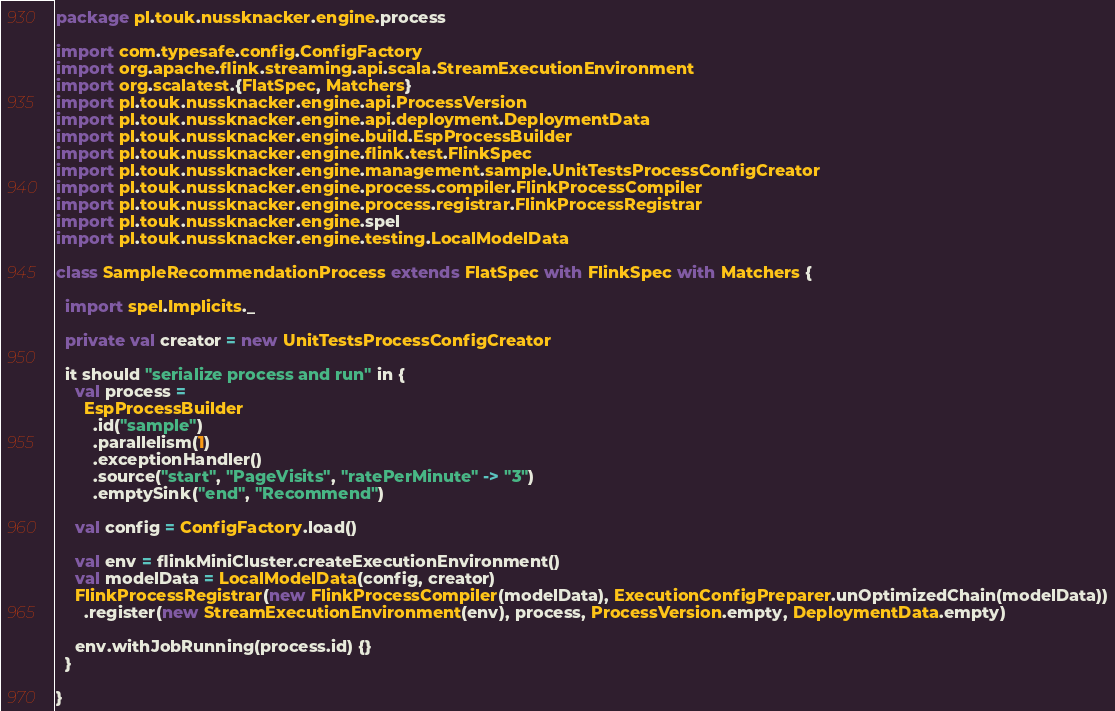Convert code to text. <code><loc_0><loc_0><loc_500><loc_500><_Scala_>package pl.touk.nussknacker.engine.process

import com.typesafe.config.ConfigFactory
import org.apache.flink.streaming.api.scala.StreamExecutionEnvironment
import org.scalatest.{FlatSpec, Matchers}
import pl.touk.nussknacker.engine.api.ProcessVersion
import pl.touk.nussknacker.engine.api.deployment.DeploymentData
import pl.touk.nussknacker.engine.build.EspProcessBuilder
import pl.touk.nussknacker.engine.flink.test.FlinkSpec
import pl.touk.nussknacker.engine.management.sample.UnitTestsProcessConfigCreator
import pl.touk.nussknacker.engine.process.compiler.FlinkProcessCompiler
import pl.touk.nussknacker.engine.process.registrar.FlinkProcessRegistrar
import pl.touk.nussknacker.engine.spel
import pl.touk.nussknacker.engine.testing.LocalModelData

class SampleRecommendationProcess extends FlatSpec with FlinkSpec with Matchers {

  import spel.Implicits._

  private val creator = new UnitTestsProcessConfigCreator

  it should "serialize process and run" in {
    val process =
      EspProcessBuilder
        .id("sample")
        .parallelism(1)
        .exceptionHandler()
        .source("start", "PageVisits", "ratePerMinute" -> "3")
        .emptySink("end", "Recommend")

    val config = ConfigFactory.load()

    val env = flinkMiniCluster.createExecutionEnvironment()
    val modelData = LocalModelData(config, creator)
    FlinkProcessRegistrar(new FlinkProcessCompiler(modelData), ExecutionConfigPreparer.unOptimizedChain(modelData))
      .register(new StreamExecutionEnvironment(env), process, ProcessVersion.empty, DeploymentData.empty)

    env.withJobRunning(process.id) {}
  }

}
</code> 